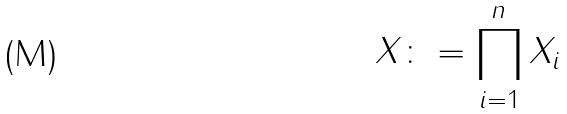Convert formula to latex. <formula><loc_0><loc_0><loc_500><loc_500>X \colon = \prod _ { i = 1 } ^ { n } X _ { i }</formula> 